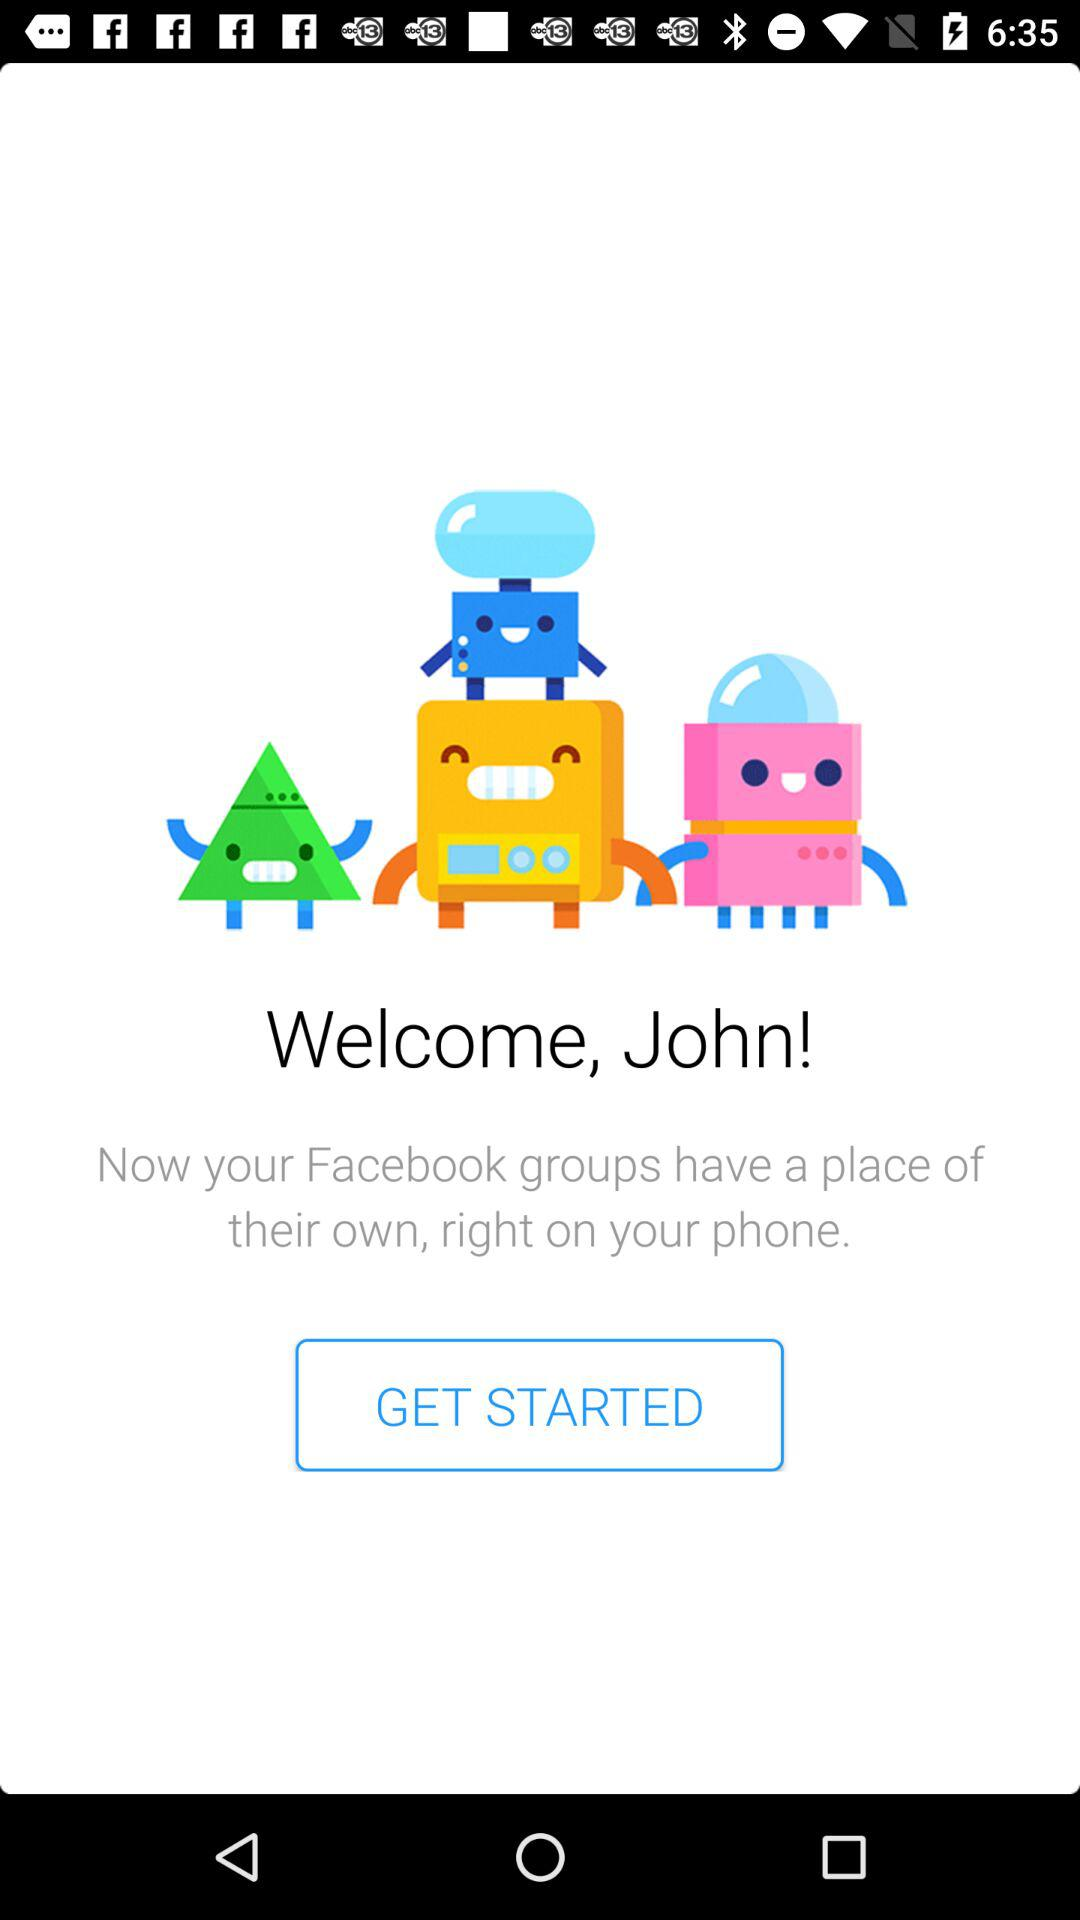How much does John weigh?
When the provided information is insufficient, respond with <no answer>. <no answer> 